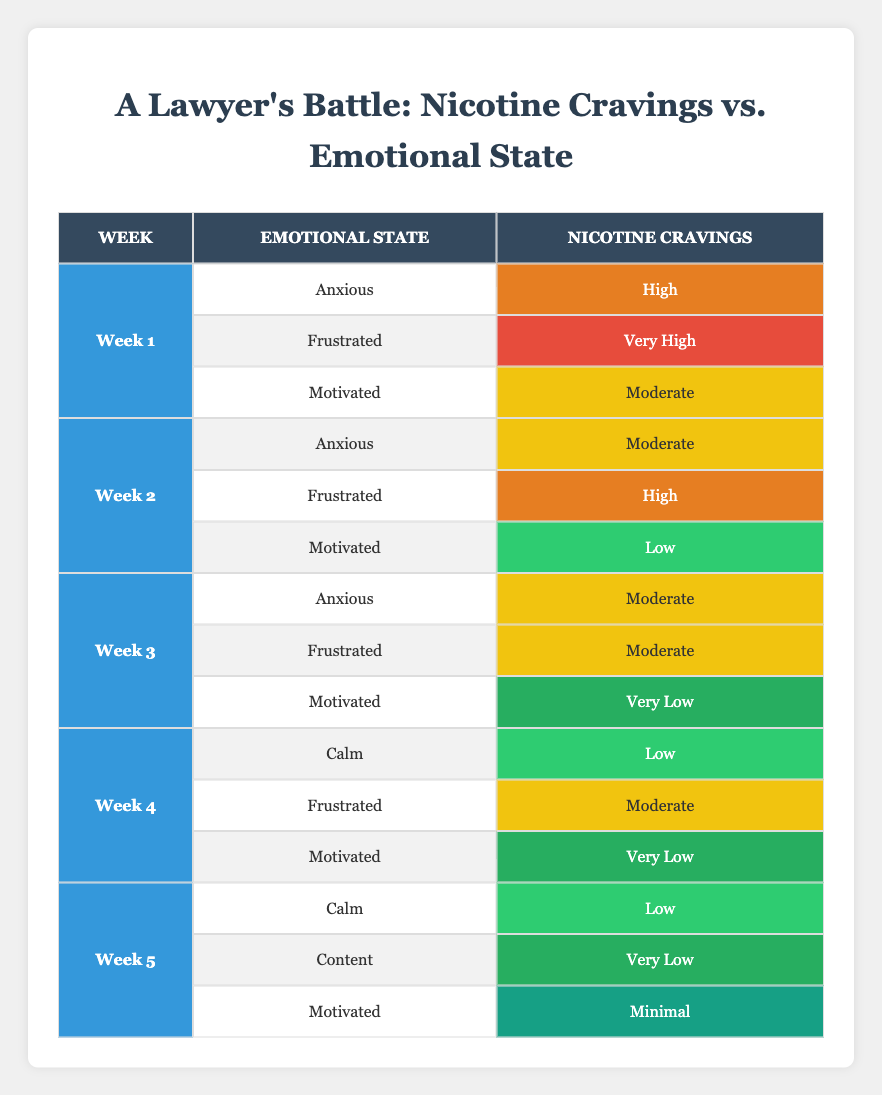What was the nicotine craving level for a motivated individual in week 1? In week 1, the nicotine craving level for a motivated individual is recorded as "Moderate" in the table.
Answer: Moderate In which week did nicotine cravings reach the highest level for anyone in the study? According to the table, week 1 shows the highest craving level, specifically noted as "Very High" for the frustrated emotional state.
Answer: Week 1 What is the average nicotine craving level for week 2? The nicotine cravings for week 2 are as follows: "Moderate" (Anxious), "High" (Frustrated), and "Low" (Motivated). Considering these levels, we categorize them as Moderate = 2, High = 3, Low = 1. The total score is 2 + 3 + 1 = 6. There are 3 states, so the average is 6/3 = 2.
Answer: 2 Did the nicotine cravings decrease for any emotional state from week 1 to week 5? By examining the table, you can see that the cravings decreased from "High" (Anxious) in week 1 to "Low" (Calm) in week 5, indicating a decrease.
Answer: Yes In week 3, which emotional state had the lowest nicotine cravings? The table shows that the motivated individual experienced "Very Low" nicotine cravings in week 3, which is lower than the other emotional states.
Answer: Motivated What emotional state had a nicotine craving record of "High" in week 2? In week 2, the emotional state of "Frustrated" corresponds to a nicotine craving level of "High" according to the table.
Answer: Frustrated How did the nicotine cravings for "Calm" individuals change from week 4 to week 5? For "Calm" individuals, the craving was "Low" in week 4 and remained "Low" in week 5. Therefore, there was no change in the craving levels between these two weeks.
Answer: No change What was the most frequent emotional state leading to high nicotine cravings across all weeks? The emotional state "Frustrated" appears twice (in weeks 1 and 2) corresponding to high nicotine cravings, thus being the most frequent state leading to high cravings.
Answer: Frustrated How many total occurrences of "Very Low" nicotine cravings are recorded in week 4? The table shows "Very Low" cravings in week 4 only for the motivated emotional state, making it a total of one occurrence.
Answer: 1 